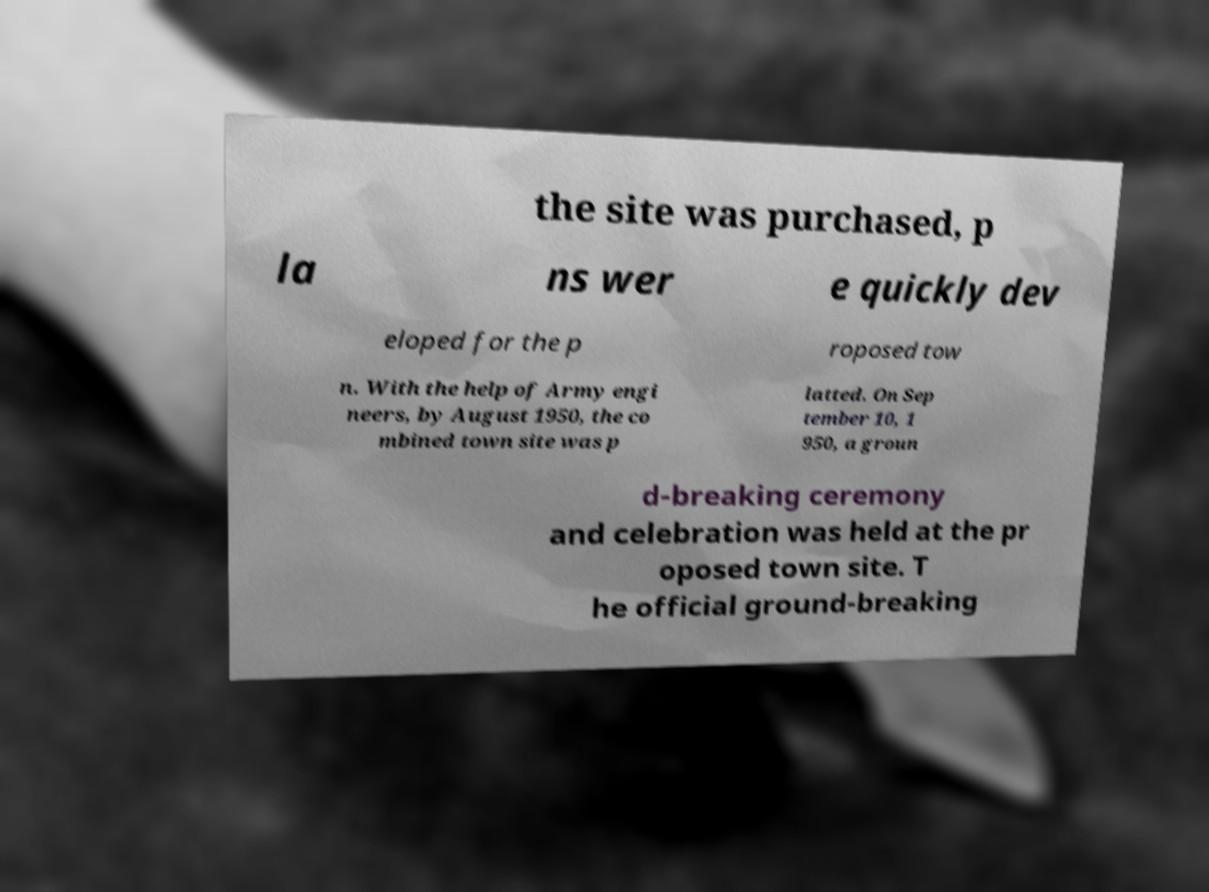For documentation purposes, I need the text within this image transcribed. Could you provide that? the site was purchased, p la ns wer e quickly dev eloped for the p roposed tow n. With the help of Army engi neers, by August 1950, the co mbined town site was p latted. On Sep tember 10, 1 950, a groun d-breaking ceremony and celebration was held at the pr oposed town site. T he official ground-breaking 